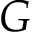Convert formula to latex. <formula><loc_0><loc_0><loc_500><loc_500>G</formula> 